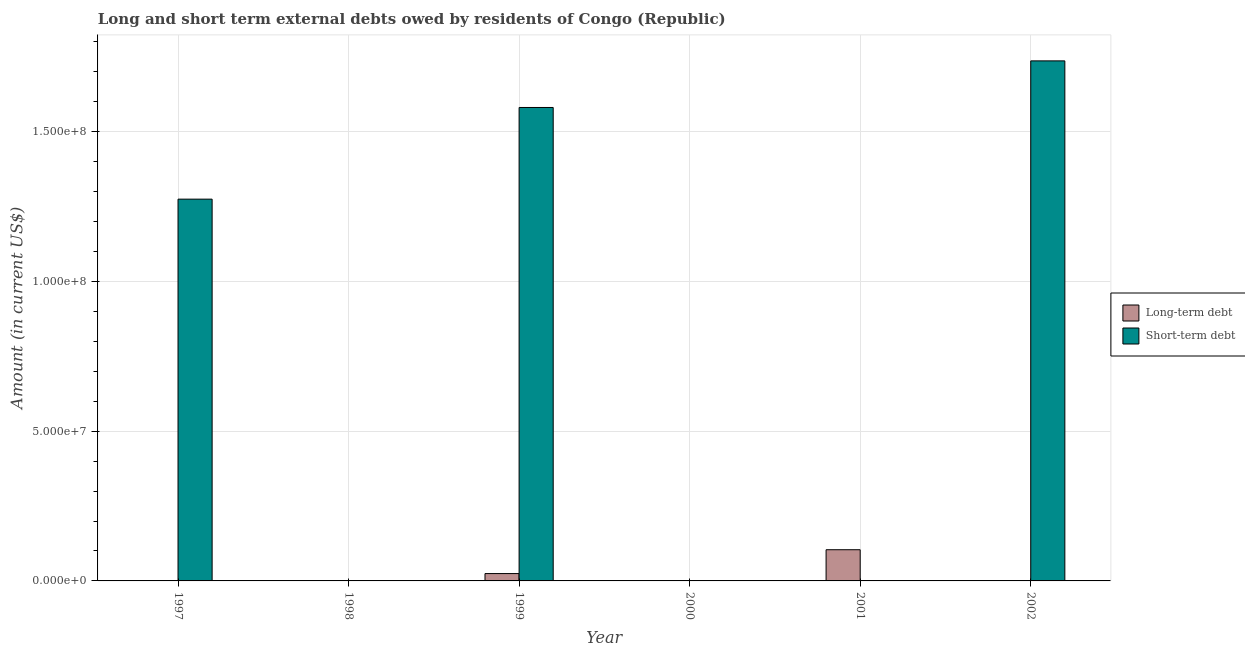What is the label of the 1st group of bars from the left?
Your answer should be compact. 1997. In how many cases, is the number of bars for a given year not equal to the number of legend labels?
Your response must be concise. 5. What is the long-term debts owed by residents in 2000?
Offer a terse response. 0. Across all years, what is the maximum long-term debts owed by residents?
Offer a terse response. 1.04e+07. Across all years, what is the minimum short-term debts owed by residents?
Your response must be concise. 0. In which year was the long-term debts owed by residents maximum?
Provide a short and direct response. 2001. What is the total long-term debts owed by residents in the graph?
Provide a succinct answer. 1.29e+07. What is the difference between the long-term debts owed by residents in 1999 and that in 2001?
Your response must be concise. -7.96e+06. What is the difference between the long-term debts owed by residents in 1998 and the short-term debts owed by residents in 1999?
Offer a terse response. -2.45e+06. What is the average short-term debts owed by residents per year?
Provide a succinct answer. 7.65e+07. In how many years, is the short-term debts owed by residents greater than 40000000 US$?
Provide a short and direct response. 3. Is the long-term debts owed by residents in 1999 less than that in 2001?
Offer a terse response. Yes. What is the difference between the highest and the second highest short-term debts owed by residents?
Your answer should be compact. 1.56e+07. What is the difference between the highest and the lowest long-term debts owed by residents?
Keep it short and to the point. 1.04e+07. Are all the bars in the graph horizontal?
Provide a short and direct response. No. What is the difference between two consecutive major ticks on the Y-axis?
Provide a succinct answer. 5.00e+07. Does the graph contain any zero values?
Offer a terse response. Yes. Does the graph contain grids?
Offer a very short reply. Yes. What is the title of the graph?
Ensure brevity in your answer.  Long and short term external debts owed by residents of Congo (Republic). Does "Malaria" appear as one of the legend labels in the graph?
Give a very brief answer. No. What is the label or title of the Y-axis?
Your response must be concise. Amount (in current US$). What is the Amount (in current US$) of Short-term debt in 1997?
Provide a short and direct response. 1.27e+08. What is the Amount (in current US$) of Long-term debt in 1999?
Your response must be concise. 2.45e+06. What is the Amount (in current US$) of Short-term debt in 1999?
Give a very brief answer. 1.58e+08. What is the Amount (in current US$) in Long-term debt in 2000?
Provide a succinct answer. 0. What is the Amount (in current US$) in Short-term debt in 2000?
Your answer should be compact. 0. What is the Amount (in current US$) of Long-term debt in 2001?
Provide a short and direct response. 1.04e+07. What is the Amount (in current US$) of Short-term debt in 2002?
Give a very brief answer. 1.74e+08. Across all years, what is the maximum Amount (in current US$) in Long-term debt?
Your response must be concise. 1.04e+07. Across all years, what is the maximum Amount (in current US$) in Short-term debt?
Your response must be concise. 1.74e+08. Across all years, what is the minimum Amount (in current US$) of Short-term debt?
Provide a succinct answer. 0. What is the total Amount (in current US$) in Long-term debt in the graph?
Offer a terse response. 1.29e+07. What is the total Amount (in current US$) of Short-term debt in the graph?
Your answer should be very brief. 4.59e+08. What is the difference between the Amount (in current US$) in Short-term debt in 1997 and that in 1999?
Your answer should be compact. -3.06e+07. What is the difference between the Amount (in current US$) of Short-term debt in 1997 and that in 2002?
Your response must be concise. -4.62e+07. What is the difference between the Amount (in current US$) of Long-term debt in 1999 and that in 2001?
Give a very brief answer. -7.96e+06. What is the difference between the Amount (in current US$) in Short-term debt in 1999 and that in 2002?
Give a very brief answer. -1.56e+07. What is the difference between the Amount (in current US$) in Long-term debt in 1999 and the Amount (in current US$) in Short-term debt in 2002?
Offer a very short reply. -1.71e+08. What is the difference between the Amount (in current US$) of Long-term debt in 2001 and the Amount (in current US$) of Short-term debt in 2002?
Offer a very short reply. -1.63e+08. What is the average Amount (in current US$) in Long-term debt per year?
Give a very brief answer. 2.14e+06. What is the average Amount (in current US$) of Short-term debt per year?
Offer a very short reply. 7.65e+07. In the year 1999, what is the difference between the Amount (in current US$) in Long-term debt and Amount (in current US$) in Short-term debt?
Your answer should be compact. -1.56e+08. What is the ratio of the Amount (in current US$) in Short-term debt in 1997 to that in 1999?
Offer a terse response. 0.81. What is the ratio of the Amount (in current US$) in Short-term debt in 1997 to that in 2002?
Offer a terse response. 0.73. What is the ratio of the Amount (in current US$) in Long-term debt in 1999 to that in 2001?
Offer a terse response. 0.24. What is the ratio of the Amount (in current US$) in Short-term debt in 1999 to that in 2002?
Your response must be concise. 0.91. What is the difference between the highest and the second highest Amount (in current US$) of Short-term debt?
Provide a short and direct response. 1.56e+07. What is the difference between the highest and the lowest Amount (in current US$) in Long-term debt?
Make the answer very short. 1.04e+07. What is the difference between the highest and the lowest Amount (in current US$) in Short-term debt?
Your answer should be very brief. 1.74e+08. 